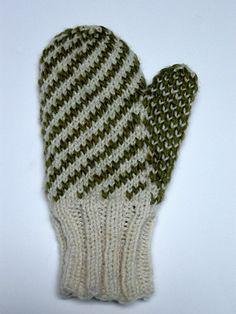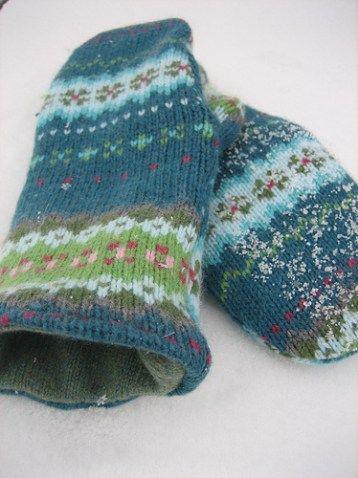The first image is the image on the left, the second image is the image on the right. Considering the images on both sides, is "Only one mitten is shown in the image on the left." valid? Answer yes or no. Yes. The first image is the image on the left, the second image is the image on the right. Assess this claim about the two images: "An image shows a pair of mittens featuring a pattern of vertical stripes and concentric diamonds.". Correct or not? Answer yes or no. No. 